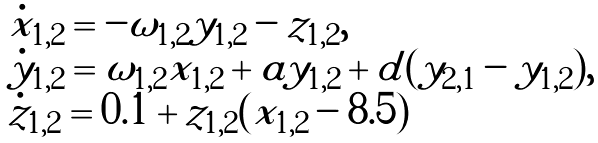<formula> <loc_0><loc_0><loc_500><loc_500>\begin{array} { l } \dot { x } _ { 1 , 2 } = - \omega _ { 1 , 2 } y _ { 1 , 2 } - z _ { 1 , 2 } , \\ \dot { y } _ { 1 , 2 } = \omega _ { 1 , 2 } x _ { 1 , 2 } + a y _ { 1 , 2 } + d ( y _ { 2 , 1 } - y _ { 1 , 2 } ) , \\ \dot { z } _ { 1 , 2 } = 0 . 1 + z _ { 1 , 2 } ( x _ { 1 , 2 } - 8 . 5 ) \end{array}</formula> 